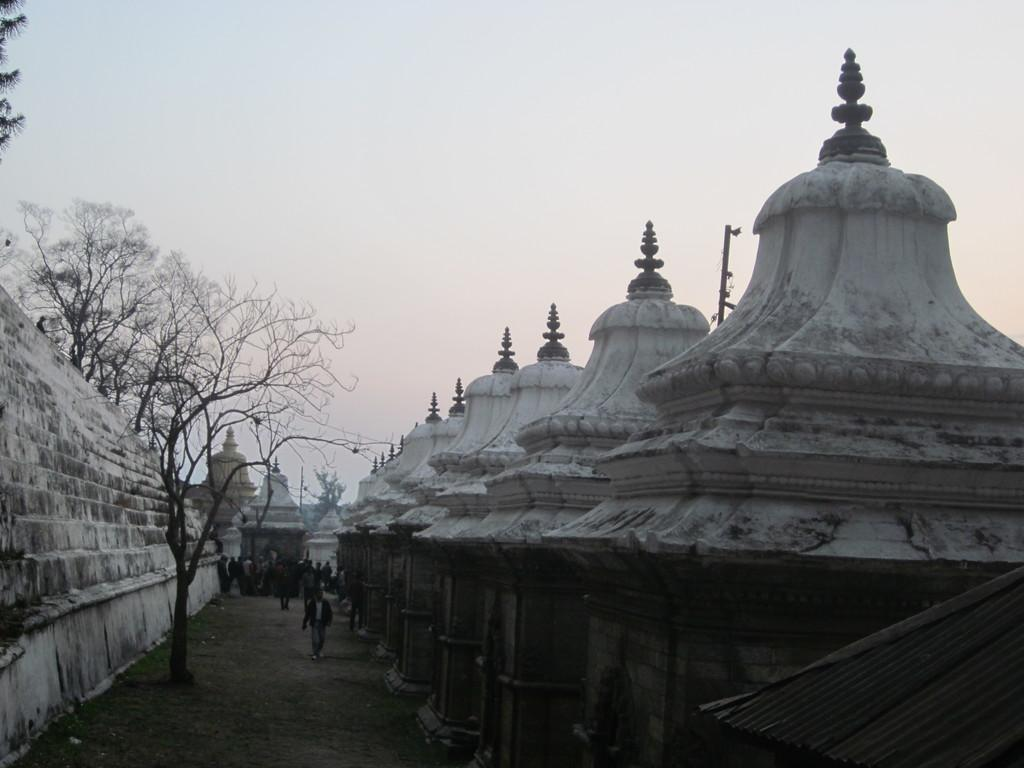What type of structures can be seen in the image? There are buildings in the image. What are the people in the image doing? There are persons walking on the ground in the image. What type of vegetation is present in the image? There are trees in the image. What is visible in the background of the image? The sky is visible in the image. What type of fuel is being used by the trees in the image? There is no indication in the image that the trees are using any fuel; trees typically produce their own energy through photosynthesis. What type of stem can be seen on the persons walking in the image? There are no stems visible on the persons walking in the image, as they are human beings and not plants. 